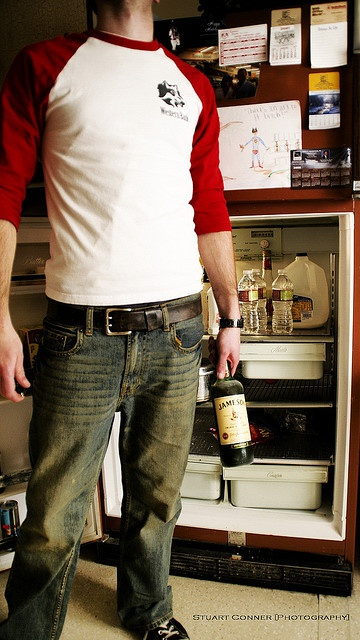Describe the objects in this image and their specific colors. I can see refrigerator in black, ivory, olive, and tan tones, people in black, white, olive, and maroon tones, bottle in black, beige, khaki, and darkgreen tones, bottle in black, tan, and olive tones, and bottle in black, tan, khaki, ivory, and maroon tones in this image. 